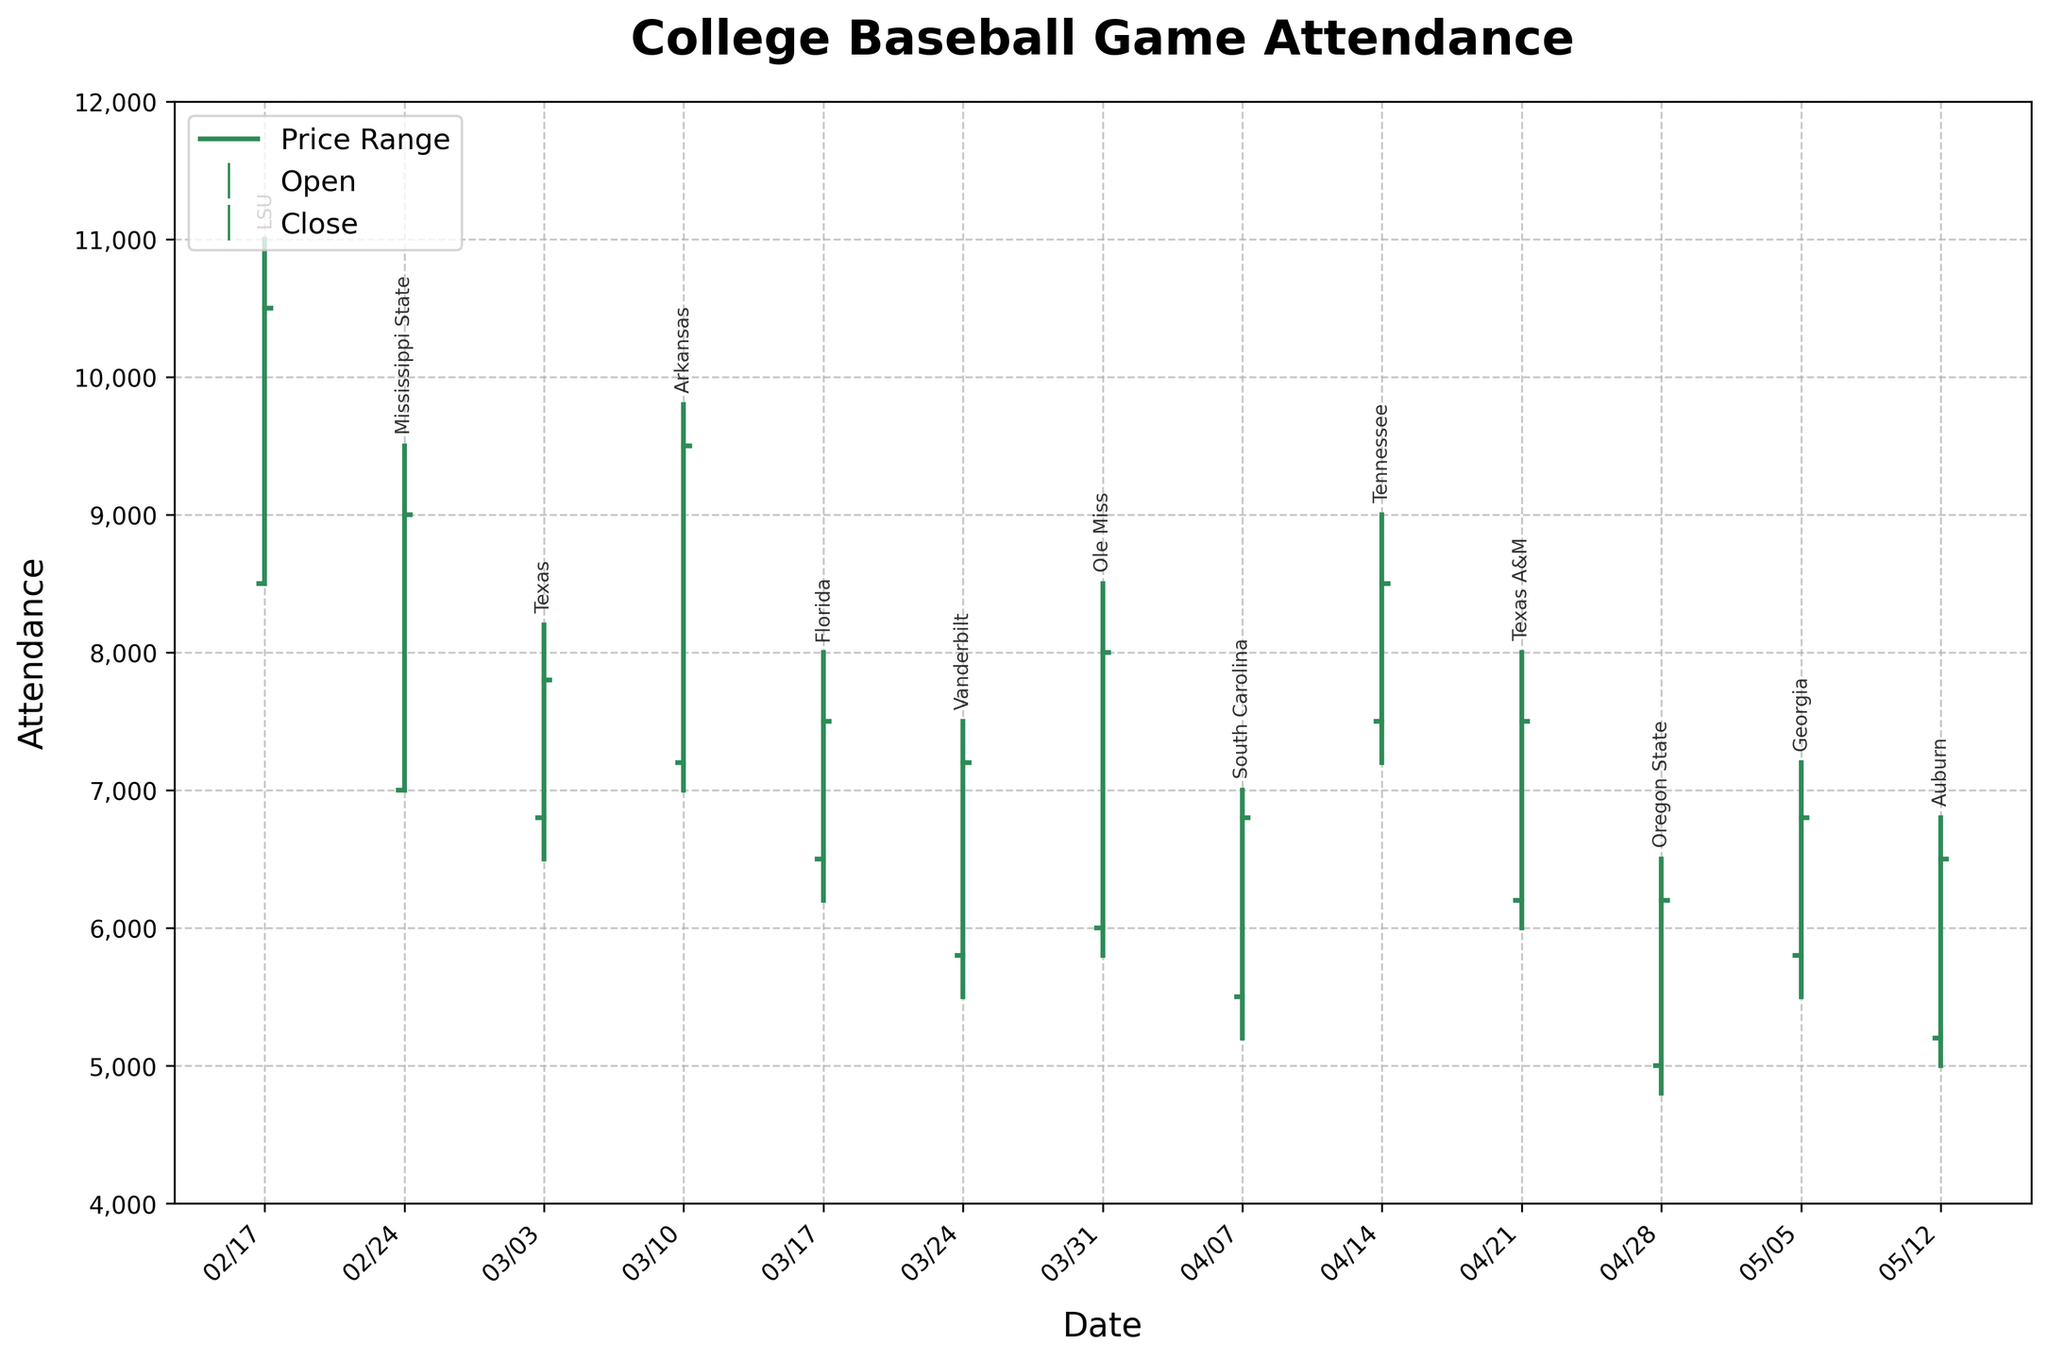What's the title of the figure? The title of the figure is usually displayed at the top. In the provided code, the title is set to "College Baseball Game Attendance".
Answer: College Baseball Game Attendance How many teams are displayed in the figure? The number of teams can be determined by counting the different data points (annotated by team names). The data lists 13 teams.
Answer: 13 What's the highest attendance recorded and for which team and date? The highest attendance can be found by identifying the maximum value in the 'High' column. LSU has the highest attendance of 11,000 on 2023-02-17.
Answer: 11,000, LSU, 2023-02-17 Which team had the lowest closing attendance? The lowest closing attendance can be found by identifying the minimum value in the 'Close' column. The provided data shows that Oregon State had the lowest closing attendance of 6,200.
Answer: Oregon State What is the average high attendance across all the teams? To find the average high attendance, sum up all the 'High' values and divide by the number of teams. Sum of High values = (11000 + 9500 + 8200 + 9800 + 8000 + 7500 + 8500 + 7000 + 9000 + 8000 + 6500 + 7200 + 6800) = 116500; number of teams = 13; so average high attendance = 116500 / 13 = 8961.54.
Answer: About 8962 Which team shows the greatest difference between its high and low attendance? Calculate the difference between 'High' and 'Low' for each team. LSU: 2500, Mississippi State: 2500, Texas: 1700, Arkansas: 2800, Florida: 1800, Vanderbilt: 2000, Ole Miss: 2700, South Carolina: 1800, Tennessee: 1800, Texas A&M: 2000, Oregon State: 1700, Georgia: 1700, Auburn: 1800. Arkansas shows the greatest difference of 2800.
Answer: Arkansas How many teams have a closing attendance greater than their opening attendance? Compare 'Close' and 'Open' for each team. LSU (10500 > 8500), Mississippi State (9000 > 7000), Arkansas (9500 > 7200), Ole Miss (8000 > 6000), Tennessee (8500 > 7500), Oregon State (6200 > 5000), Georgia (6800 > 5800). 7 teams satisfy this condition.
Answer: 7 For which team is the closing attendance exactly equal to the opening attendance? Compare 'Close' and 'Open' for each team. No team in the provided data has a closing attendance exactly equal to their opening attendance.
Answer: None What's the median closing attendance? To find the median, list the 'Close' values in ascending order: [6200, 6500, 6800, 6800, 7200, 7500, 7500, 7800, 8000, 8500, 9000, 9500, 10500]. The middle value (7th in this sorted list) is 7500.
Answer: 7500 Which team had the highest opening attendance? The highest opening attendance can be found by identifying the maximum value in the 'Open' column. LSU has the highest opening attendance of 8,500.
Answer: LSU 